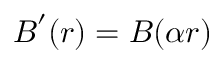Convert formula to latex. <formula><loc_0><loc_0><loc_500><loc_500>\boldsymbol B ^ { \prime } ( r ) = \boldsymbol B ( \alpha r )</formula> 